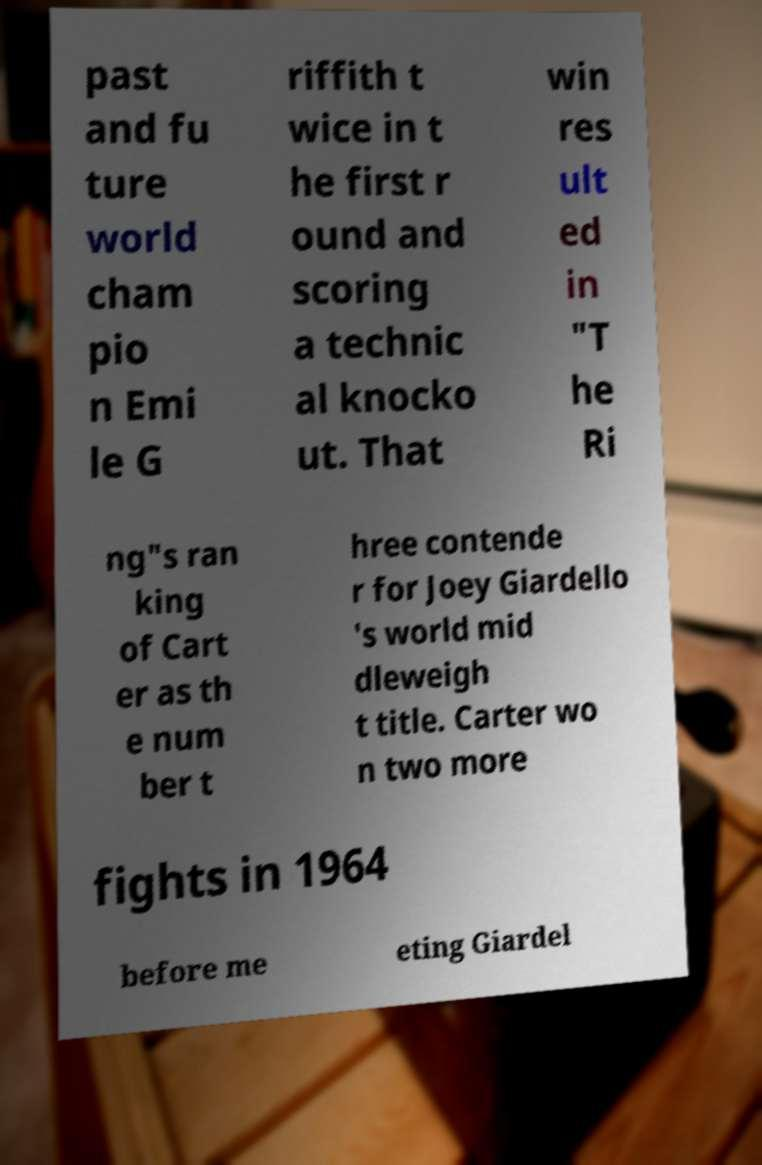What messages or text are displayed in this image? I need them in a readable, typed format. past and fu ture world cham pio n Emi le G riffith t wice in t he first r ound and scoring a technic al knocko ut. That win res ult ed in "T he Ri ng"s ran king of Cart er as th e num ber t hree contende r for Joey Giardello 's world mid dleweigh t title. Carter wo n two more fights in 1964 before me eting Giardel 